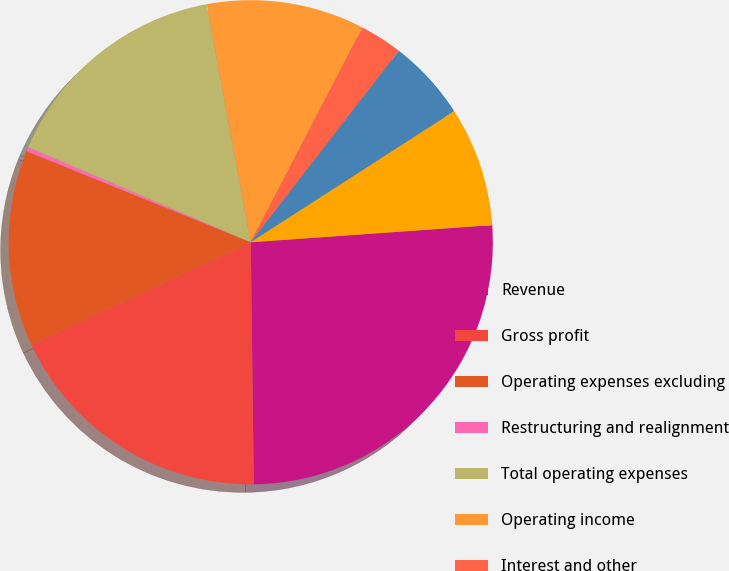Convert chart. <chart><loc_0><loc_0><loc_500><loc_500><pie_chart><fcel>Revenue<fcel>Gross profit<fcel>Operating expenses excluding<fcel>Restructuring and realignment<fcel>Total operating expenses<fcel>Operating income<fcel>Interest and other<fcel>Income tax expense<fcel>Net income<nl><fcel>25.93%<fcel>18.23%<fcel>13.11%<fcel>0.28%<fcel>15.67%<fcel>10.54%<fcel>2.85%<fcel>5.41%<fcel>7.98%<nl></chart> 